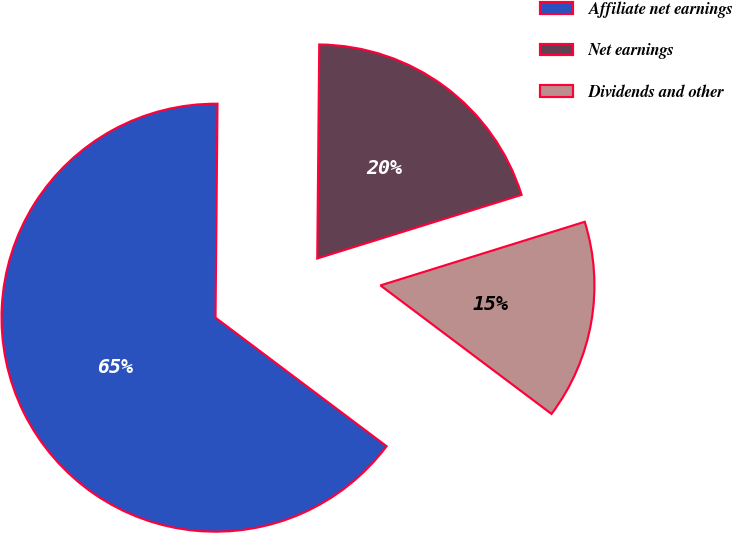<chart> <loc_0><loc_0><loc_500><loc_500><pie_chart><fcel>Affiliate net earnings<fcel>Net earnings<fcel>Dividends and other<nl><fcel>64.89%<fcel>20.05%<fcel>15.06%<nl></chart> 